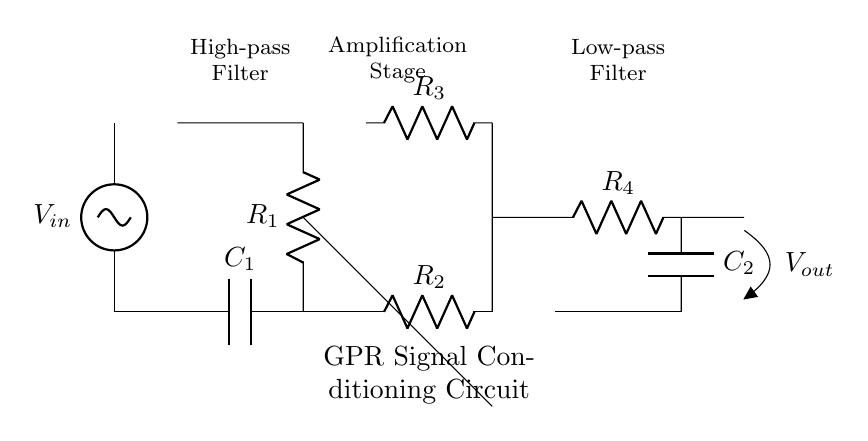What is the input voltage of this circuit? The input voltage is labeled as V_in, which means it represents the voltage applied at the beginning of the circuit.
Answer: V_in What type of filter is used at the beginning of the circuit? The first component after the input is a capacitor, connected in series with a resistor, indicating it is a high-pass filter which allows high-frequency signals to pass while attenuating low frequencies.
Answer: High-pass filter What does the operational amplifier do in this circuit? The operational amplifier amplifies the signal coming from the high-pass filter, allowing it to strengthen the desired signal before further processing.
Answer: Amplification What components make up the low-pass filter in this circuit? The low-pass filter consists of a resistor and a capacitor placed in series, allowing low frequency signals to pass while attenuating higher frequencies.
Answer: Resistor and capacitor How many stages are there in this signal conditioning circuit? The circuit contains three main stages: the high-pass filter, the amplification stage, and the low-pass filter. Each stage modifies the signal in a way suitable for ground-penetrating radar data processing.
Answer: Three stages What is the output of this circuit labeled as? The output is labeled as V_out, which indicates the processed signal that will be sent from the circuit.
Answer: V_out 